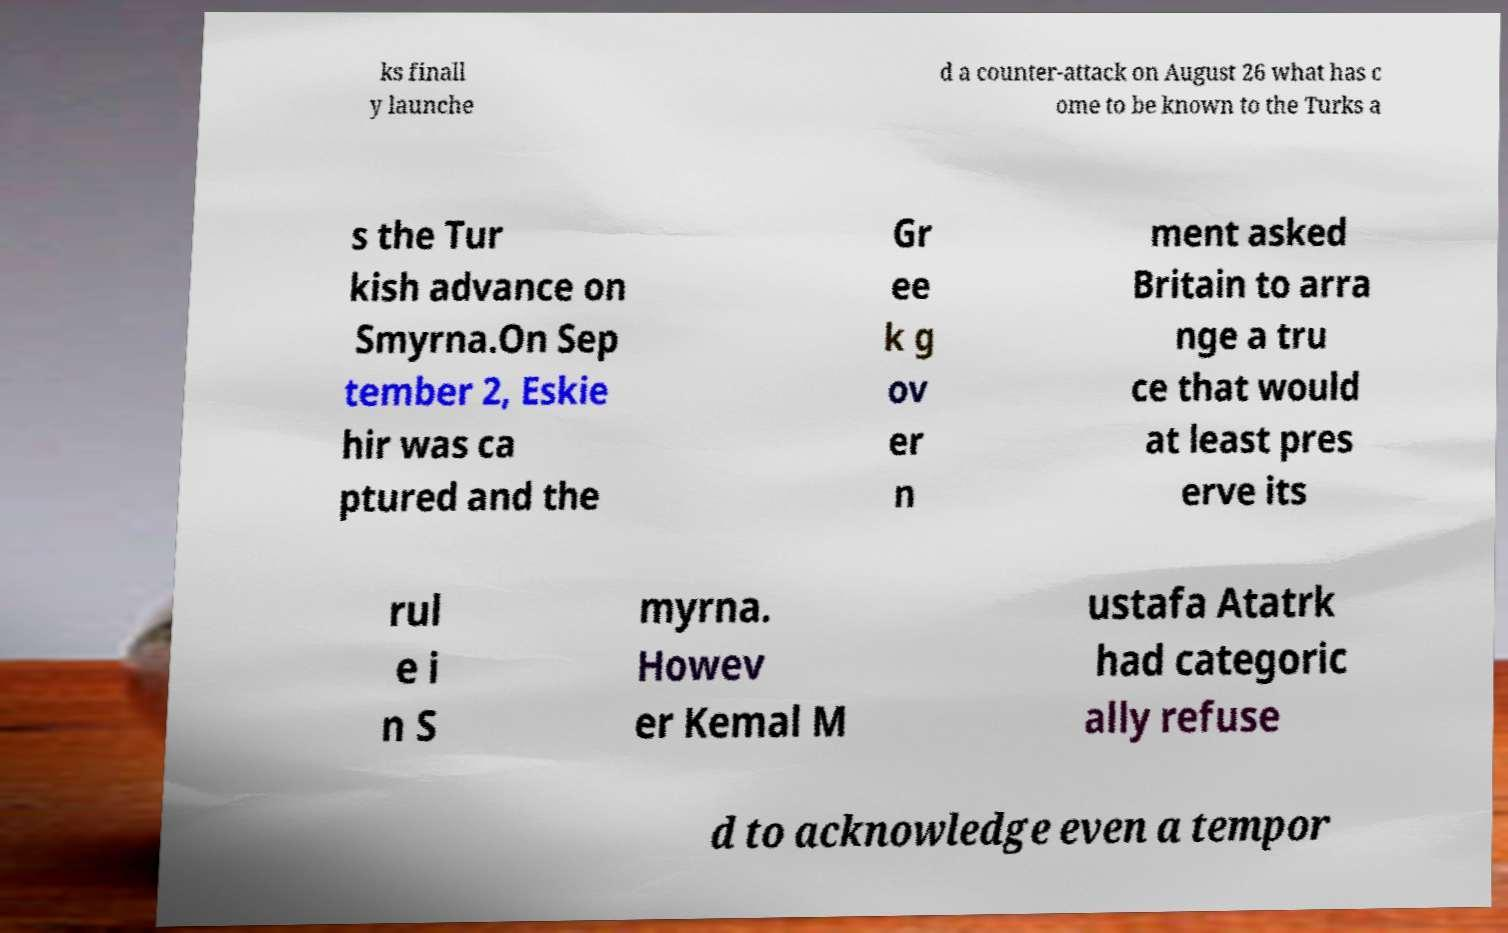There's text embedded in this image that I need extracted. Can you transcribe it verbatim? ks finall y launche d a counter-attack on August 26 what has c ome to be known to the Turks a s the Tur kish advance on Smyrna.On Sep tember 2, Eskie hir was ca ptured and the Gr ee k g ov er n ment asked Britain to arra nge a tru ce that would at least pres erve its rul e i n S myrna. Howev er Kemal M ustafa Atatrk had categoric ally refuse d to acknowledge even a tempor 